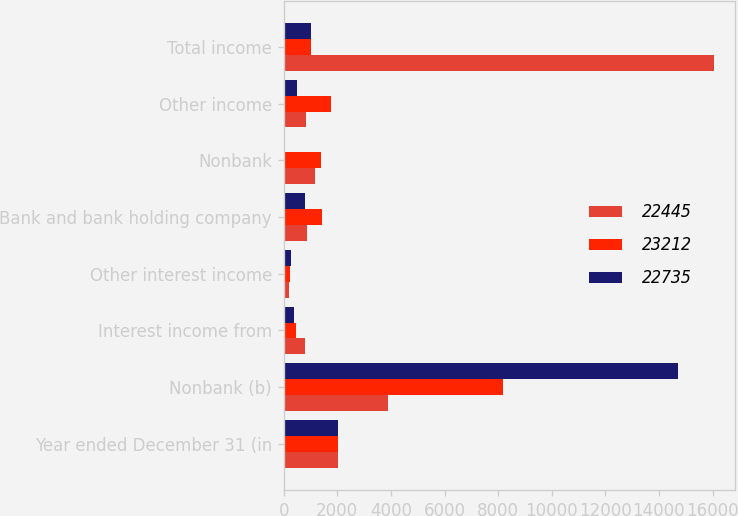Convert chart to OTSL. <chart><loc_0><loc_0><loc_500><loc_500><stacked_bar_chart><ecel><fcel>Year ended December 31 (in<fcel>Nonbank (b)<fcel>Interest income from<fcel>Other interest income<fcel>Bank and bank holding company<fcel>Nonbank<fcel>Other income<fcel>Total income<nl><fcel>22445<fcel>2016<fcel>3873<fcel>794<fcel>207<fcel>852<fcel>1165<fcel>846<fcel>16045<nl><fcel>23212<fcel>2015<fcel>8172<fcel>443<fcel>234<fcel>1438<fcel>1402<fcel>1773<fcel>1008.5<nl><fcel>22735<fcel>2014<fcel>14716<fcel>378<fcel>284<fcel>779<fcel>52<fcel>508<fcel>1008.5<nl></chart> 